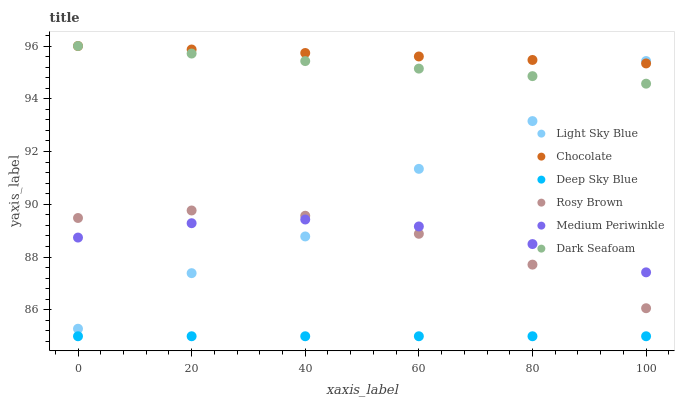Does Deep Sky Blue have the minimum area under the curve?
Answer yes or no. Yes. Does Chocolate have the maximum area under the curve?
Answer yes or no. Yes. Does Medium Periwinkle have the minimum area under the curve?
Answer yes or no. No. Does Medium Periwinkle have the maximum area under the curve?
Answer yes or no. No. Is Deep Sky Blue the smoothest?
Answer yes or no. Yes. Is Light Sky Blue the roughest?
Answer yes or no. Yes. Is Medium Periwinkle the smoothest?
Answer yes or no. No. Is Medium Periwinkle the roughest?
Answer yes or no. No. Does Deep Sky Blue have the lowest value?
Answer yes or no. Yes. Does Medium Periwinkle have the lowest value?
Answer yes or no. No. Does Dark Seafoam have the highest value?
Answer yes or no. Yes. Does Medium Periwinkle have the highest value?
Answer yes or no. No. Is Deep Sky Blue less than Dark Seafoam?
Answer yes or no. Yes. Is Chocolate greater than Rosy Brown?
Answer yes or no. Yes. Does Dark Seafoam intersect Chocolate?
Answer yes or no. Yes. Is Dark Seafoam less than Chocolate?
Answer yes or no. No. Is Dark Seafoam greater than Chocolate?
Answer yes or no. No. Does Deep Sky Blue intersect Dark Seafoam?
Answer yes or no. No. 